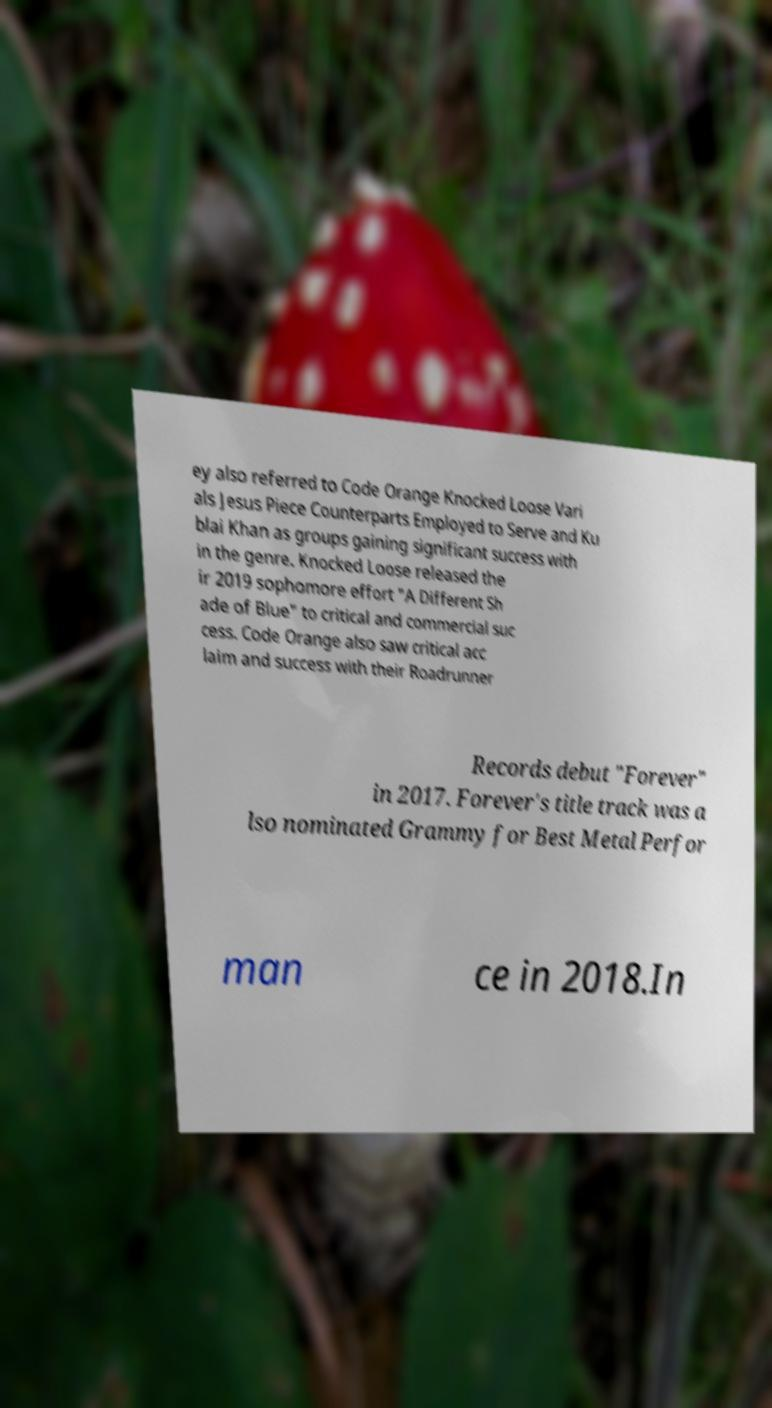What messages or text are displayed in this image? I need them in a readable, typed format. ey also referred to Code Orange Knocked Loose Vari als Jesus Piece Counterparts Employed to Serve and Ku blai Khan as groups gaining significant success with in the genre. Knocked Loose released the ir 2019 sophomore effort "A Different Sh ade of Blue" to critical and commercial suc cess. Code Orange also saw critical acc laim and success with their Roadrunner Records debut "Forever" in 2017. Forever's title track was a lso nominated Grammy for Best Metal Perfor man ce in 2018.In 